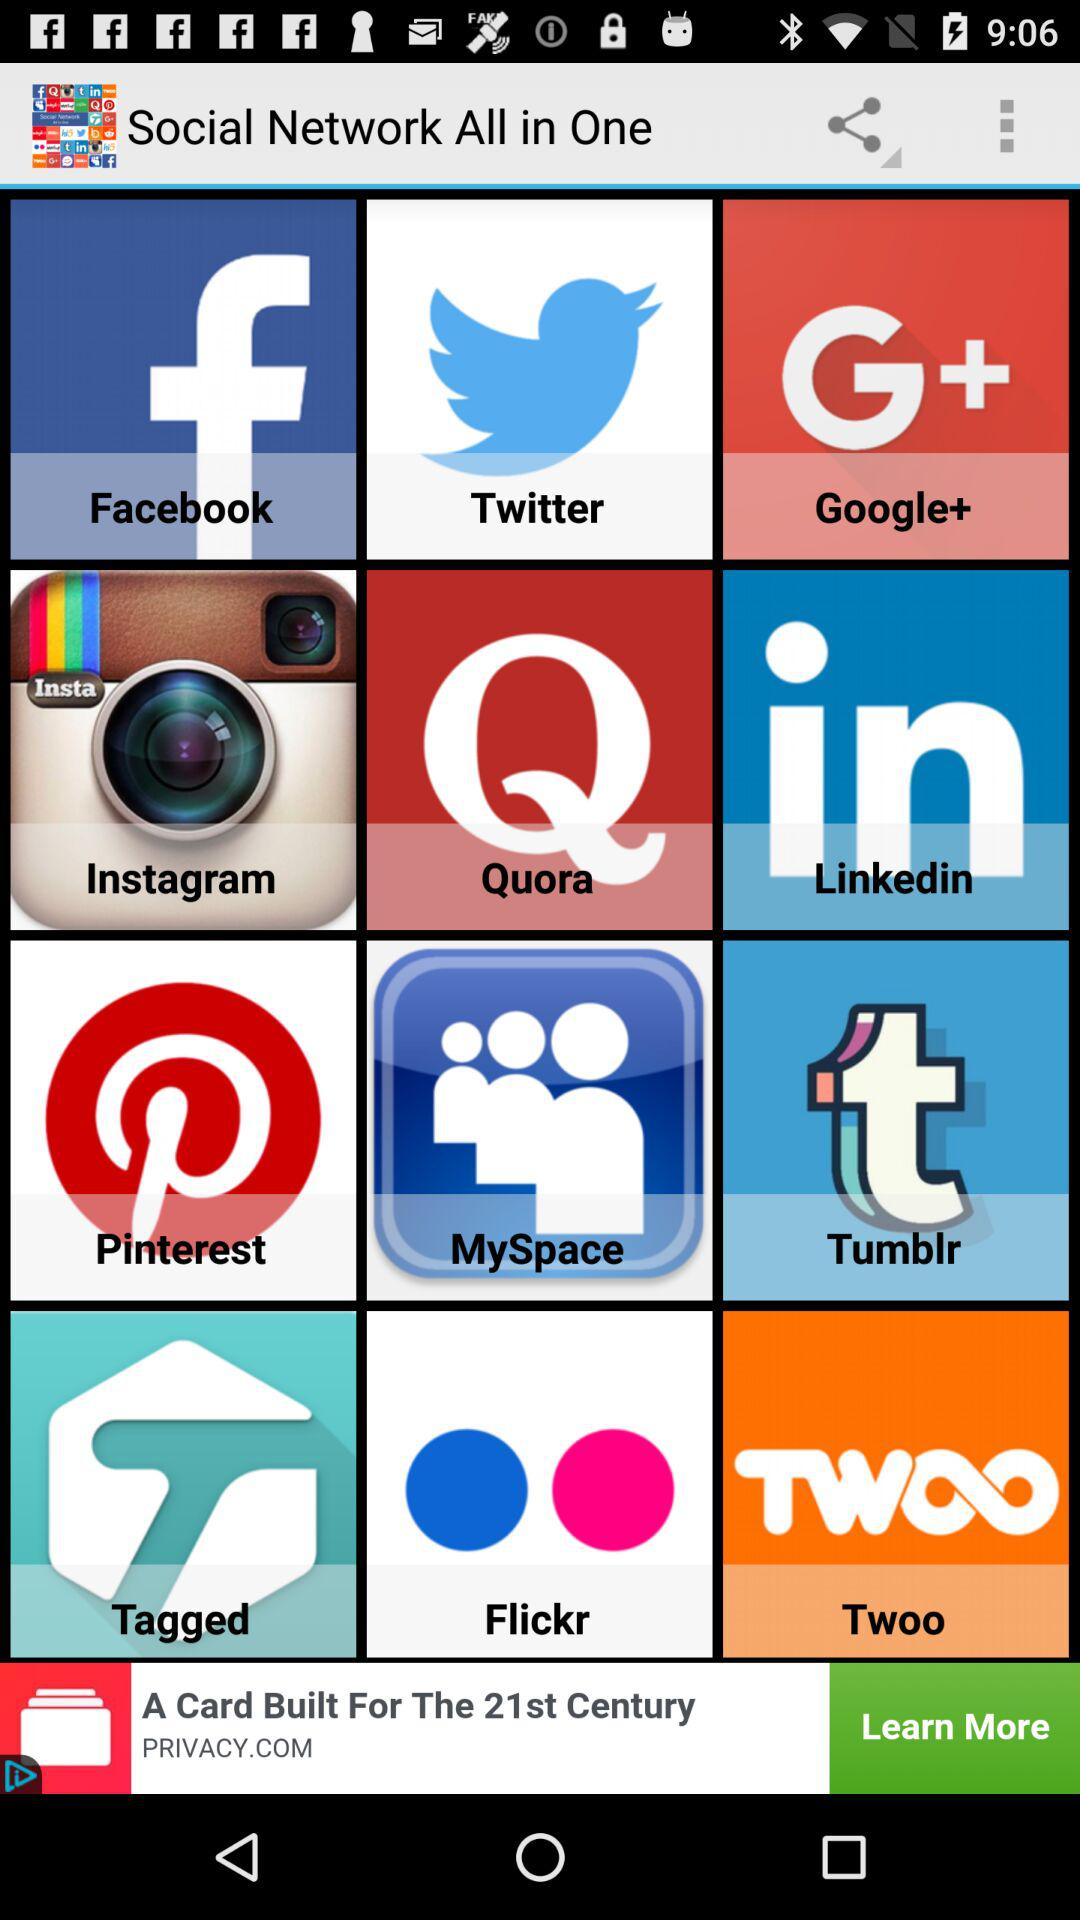What is the application name? The application name is "Social Network All in One". 